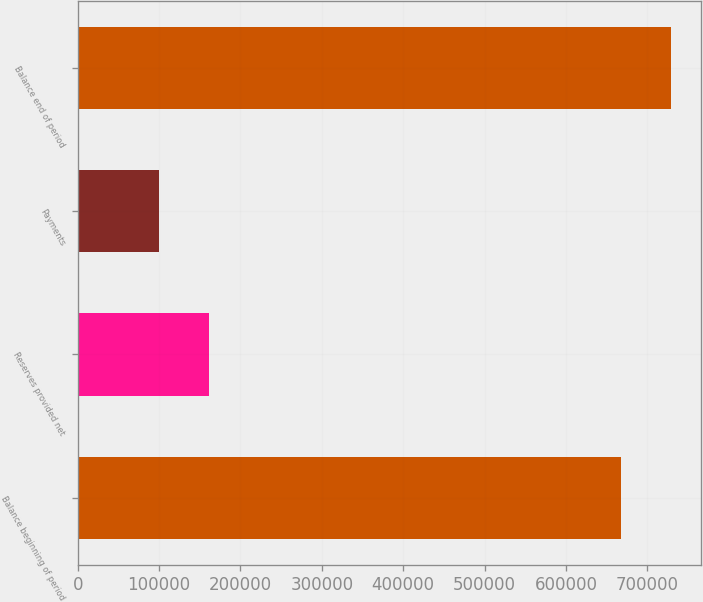Convert chart. <chart><loc_0><loc_0><loc_500><loc_500><bar_chart><fcel>Balance beginning of period<fcel>Reserves provided net<fcel>Payments<fcel>Balance end of period<nl><fcel>668100<fcel>160705<fcel>99645<fcel>729160<nl></chart> 